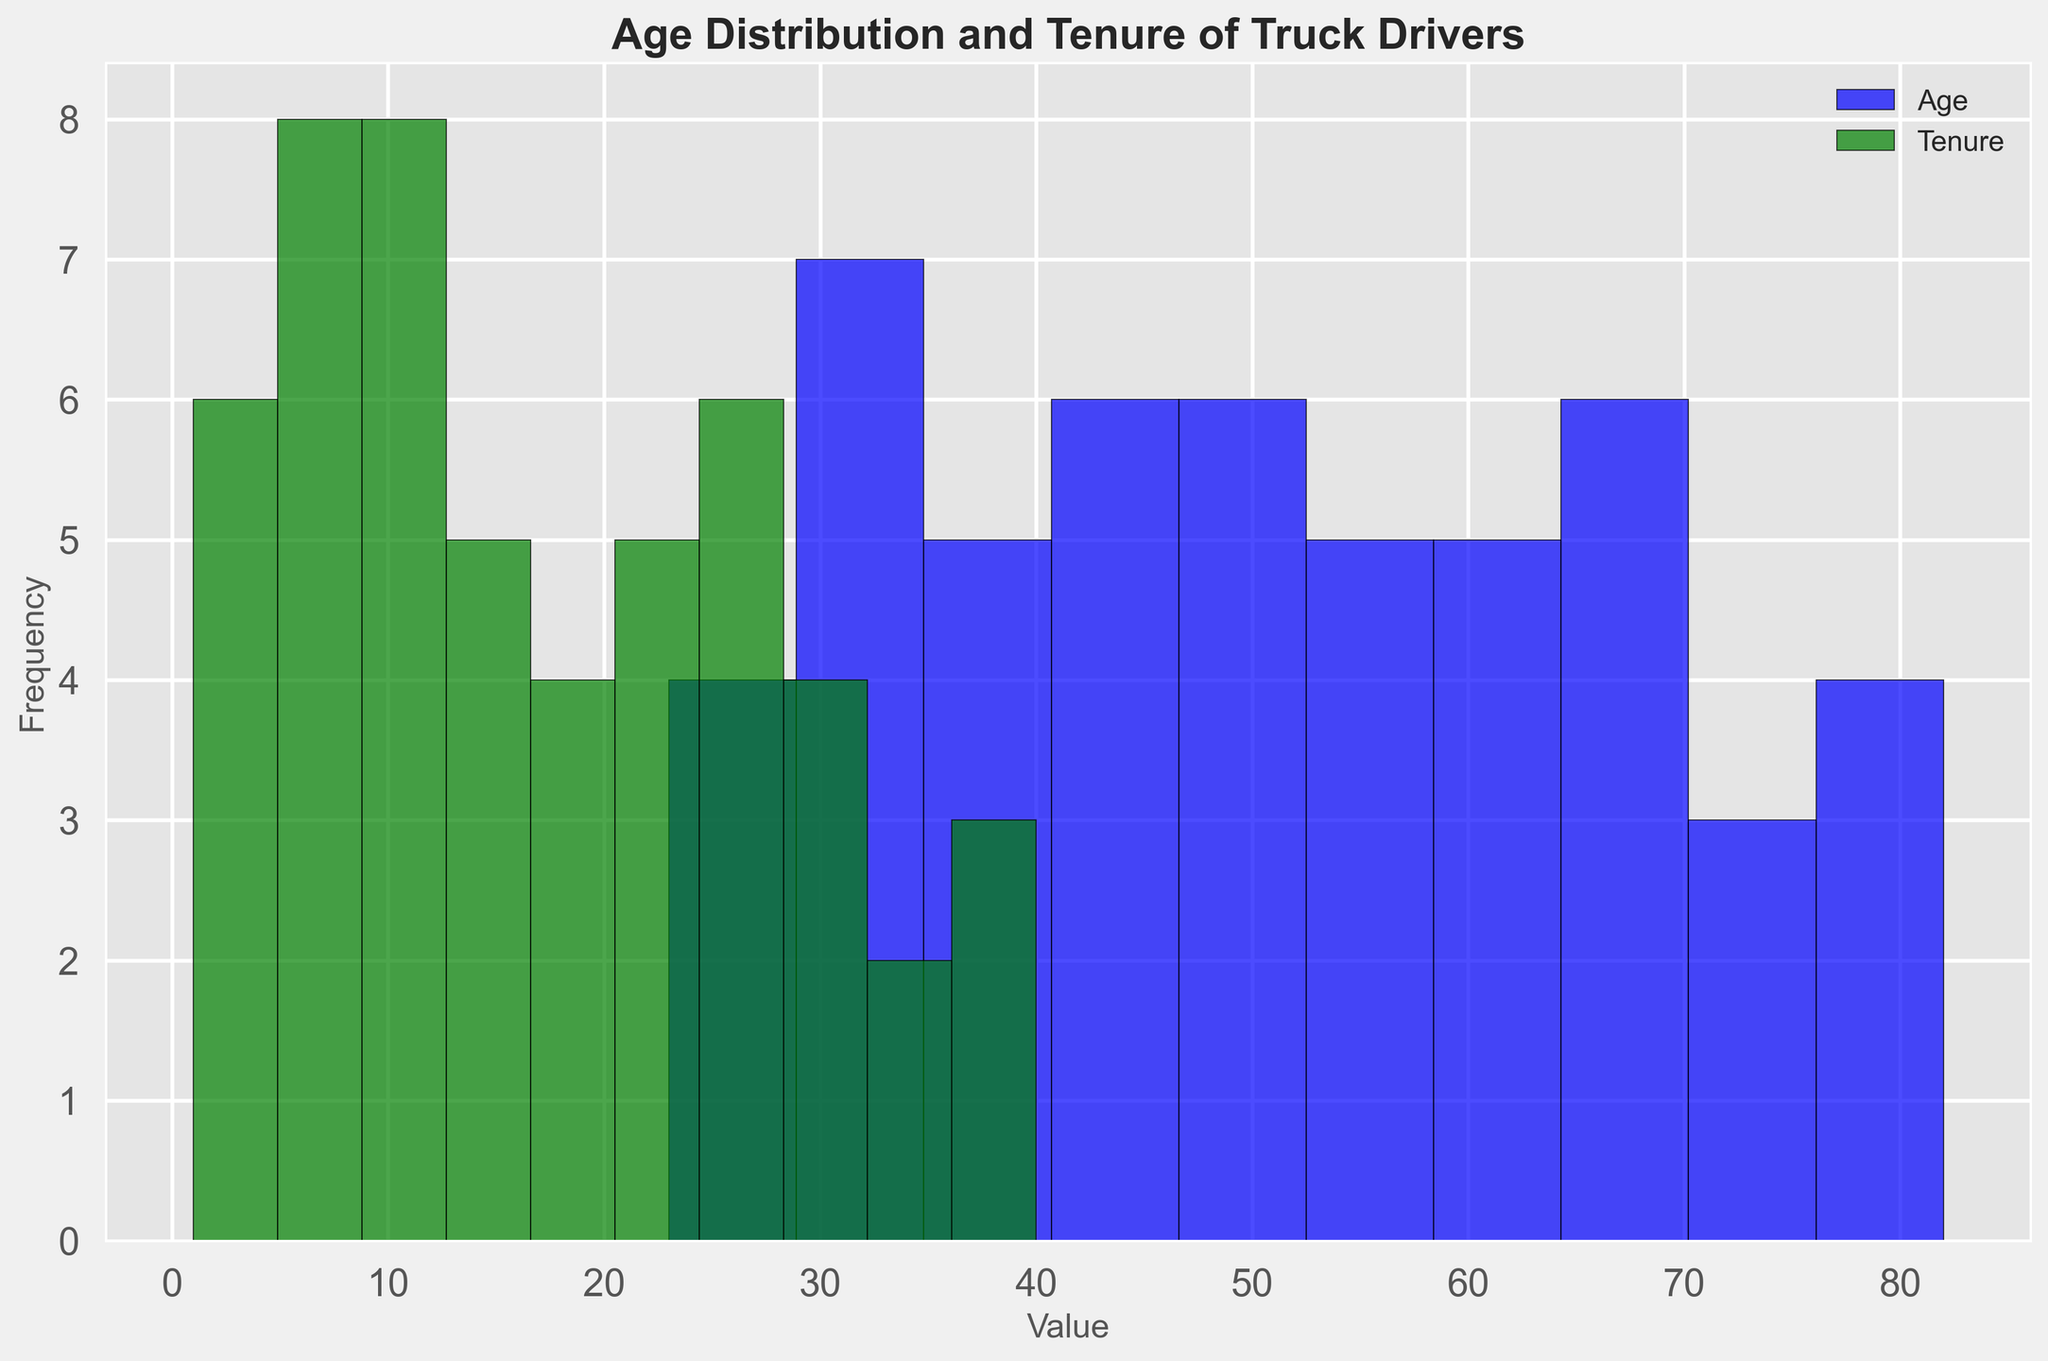what's the average age of truck drivers? To find the average age, add up all the age values and divide by the number of drivers. The sum of ages is (23 + 25 + 27 + 31 + 34 + 36 + 39 + 42 + 45 + 47 + 50 + 52 + 55 + 57 + 60 + 62 + 65 + 67 + 40 + 38 + 34 + 29 + 26 + 32 + 35 + 49 + 51 + 54 + 58 + 61 + 64 + 66 + 70 + 71 + 30 + 48 + 43 + 41 + 46 + 63 + 68 + 69 + 33 + 44 + 53 + 73 + 75 + 77 + 79 + 81 + 82) = 2570, divided by the number of drivers (51), so 2570 / 51 = 50.39
Answer: 50.39 Which age or tenure group is the largest? By looking at the histogram, find the bins with the highest bar. Compare both age and tenure groups to see which has more drivers.
Answer: The age group 50-59 is the largest What is the median value of tenure? To find the median, list all tenure values in numerical order and find the middle number. In this case, there's an even number of tenures, so the median will be the average of the 25th and 26th values.
Answer: 16.5 Is there a noticeable trend between age and tenure of truck drivers? Observe the histograms’ shapes and heights. Patterns can indicate if older drivers tend to have longer tenures and vice versa.
Answer: Yes, generally, older drivers tend to have longer tenures Which age group first reaches a tenure of over 20 years? Identify the age groups in the tenure histogram that surpass the 20-year mark and find the corresponding age from the age histogram.
Answer: Age group 55-64 Between which age intervals do most drivers fall? Look for the tallest bars in the age histogram to determine the intervals with the highest frequencies.
Answer: 50-59 Are there more drivers aged above 60 or with tenure above 20 years? Compare the frequencies within the histograms for the age group over 60 and the tenure over 20.
Answer: More drivers with tenure above 20 years What color represents the tenure in the histogram? Identify the color used in the histogram for the tenure.
Answer: Green Which value group has more frequent small values, age or tenure? Compare the left side of both histograms to see which histogram has higher bars in the initial bins, indicating a higher frequency of small values.
Answer: Age What is the age range shown in this histogram? Look at the lowest and highest points of the age histogram and subtract the smallest age from the largest age.
Answer: 23-82 